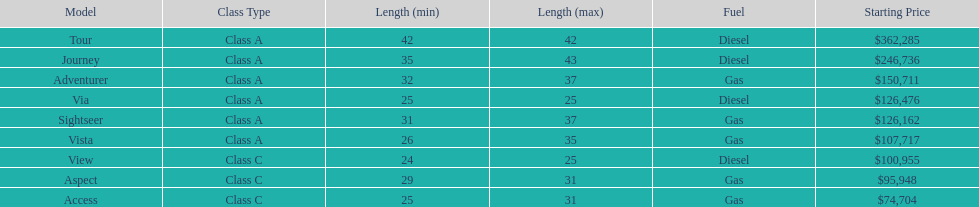Which model is a diesel, the tour or the aspect? Tour. 